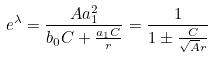<formula> <loc_0><loc_0><loc_500><loc_500>e ^ { \lambda } = \frac { A a _ { 1 } ^ { 2 } } { b _ { 0 } C + \frac { a _ { 1 } C } { r } } = \frac { 1 } { 1 \pm \frac { C } { \sqrt { A } r } }</formula> 